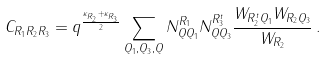Convert formula to latex. <formula><loc_0><loc_0><loc_500><loc_500>C _ { R _ { 1 } R _ { 2 } R _ { 3 } } = q ^ { \frac { \kappa _ { R _ { 2 } } + \kappa _ { R _ { 3 } } } 2 } \sum _ { Q _ { 1 } , Q _ { 3 } , Q } N _ { Q Q _ { 1 } } ^ { R _ { 1 } } N _ { Q Q _ { 3 } } ^ { R _ { 3 } ^ { t } } \frac { W _ { R _ { 2 } ^ { t } Q _ { 1 } } W _ { R _ { 2 } Q _ { 3 } } } { W _ { R _ { 2 } } } \, .</formula> 